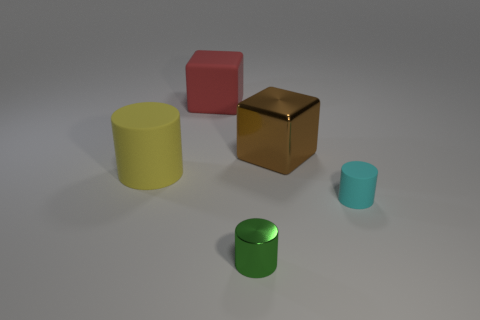Add 2 yellow rubber cylinders. How many objects exist? 7 Subtract all cylinders. How many objects are left? 2 Add 1 big gray cubes. How many big gray cubes exist? 1 Subtract 0 purple cubes. How many objects are left? 5 Subtract all tiny green shiny cylinders. Subtract all big red matte blocks. How many objects are left? 3 Add 4 small cyan rubber things. How many small cyan rubber things are left? 5 